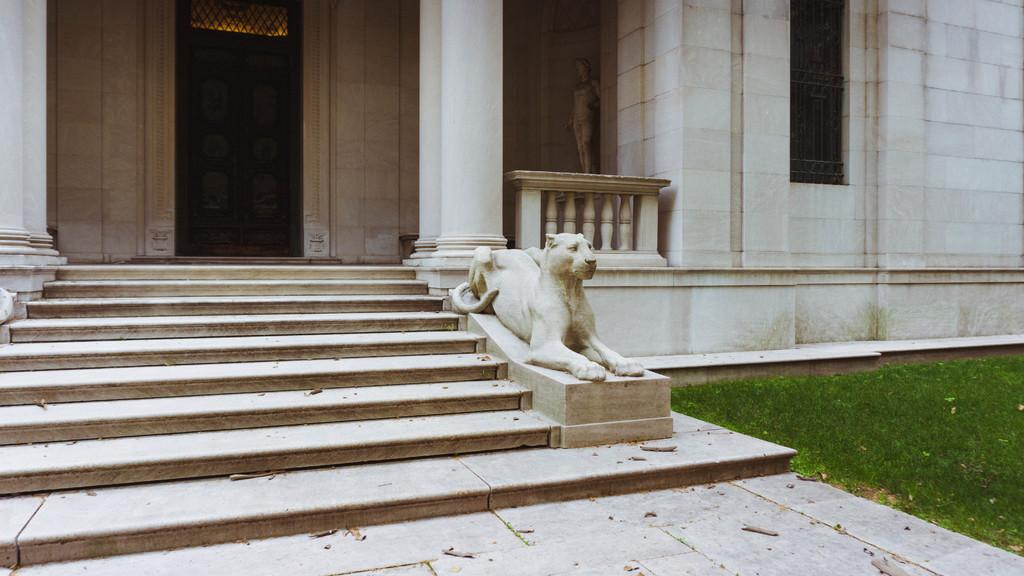What is the main structure in the center of the image? There is a building in the center of the image. What can be found at the bottom of the image? There is a sculpture and stairs at the bottom of the image. What type of vegetation is on the right side of the image? There is grass on the right side of the image. What does the building need to learn in order to improve its performance? The building is an inanimate object and does not have the ability to learn or improve its performance. 